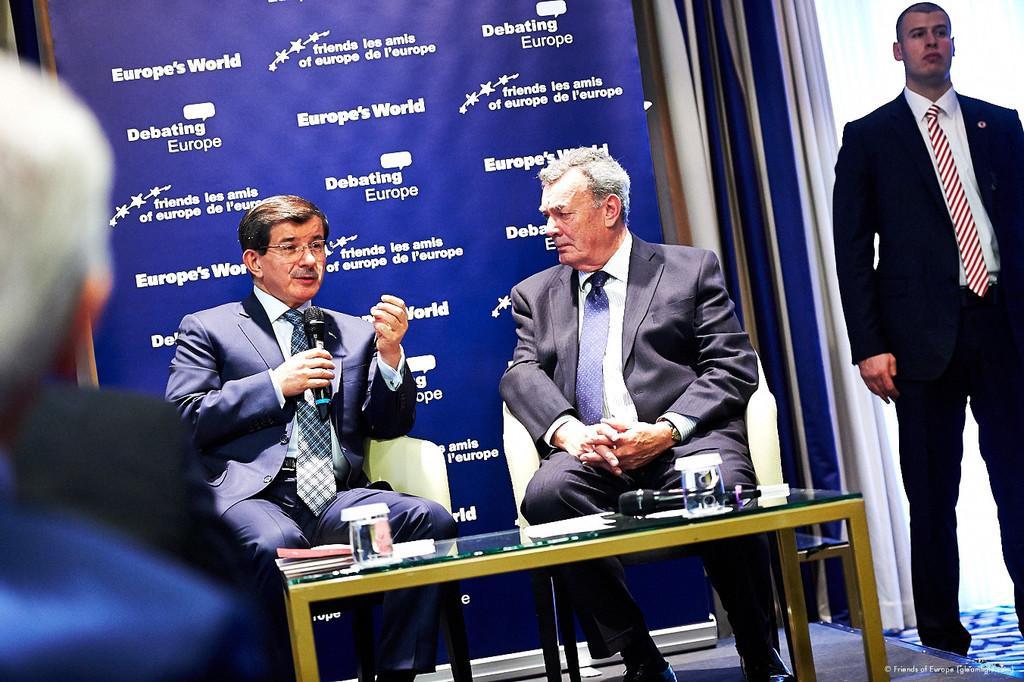Can you describe this image briefly? In this picture we can see there are three people sitting on chairs and a man is standing on the path and a man is holding a microphone. In front of the people there is a table and on the table there are glasses, papers and a microphone. Behind the people there is a banner and curtains. 